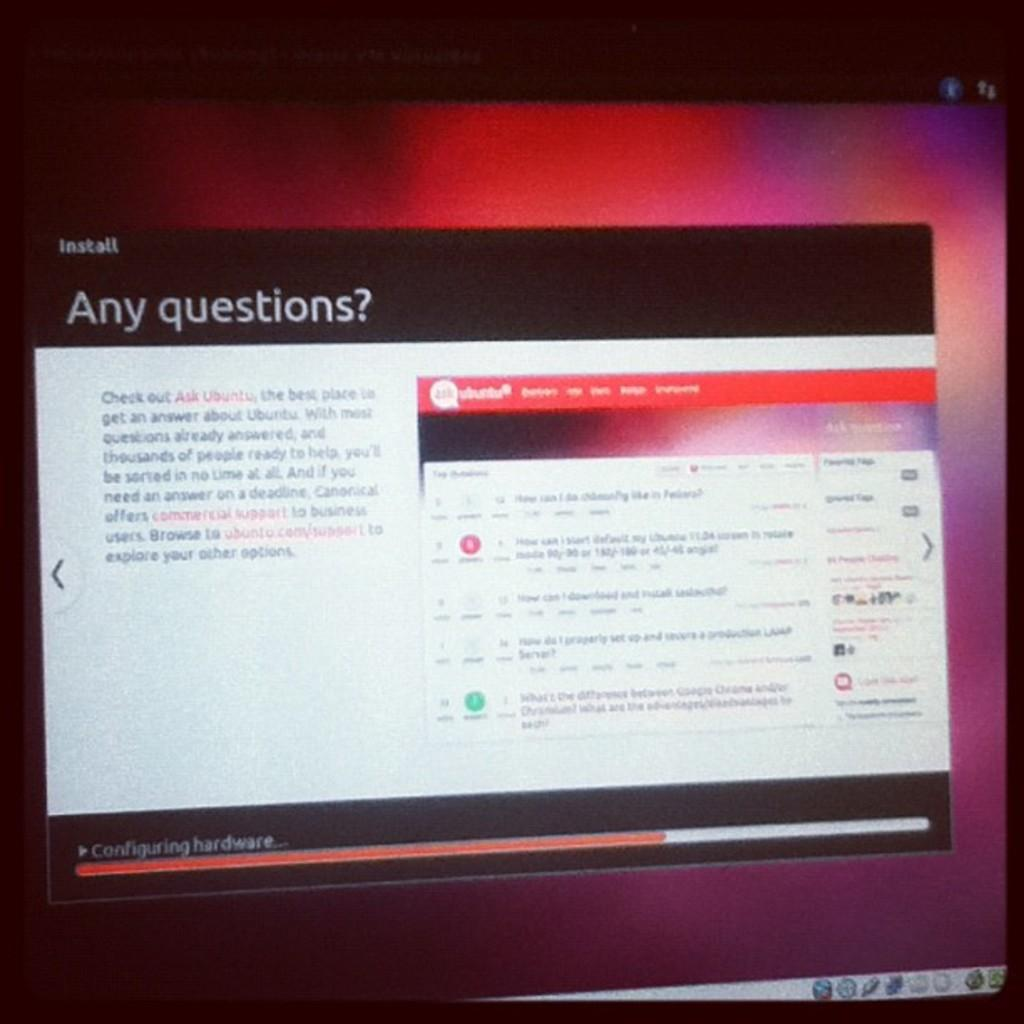<image>
Provide a brief description of the given image. A computer screen with the words "any questions?" at the top. 